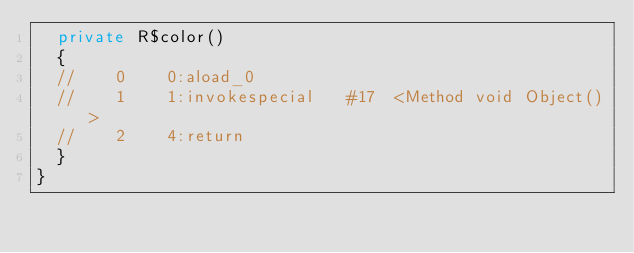Convert code to text. <code><loc_0><loc_0><loc_500><loc_500><_Java_>	private R$color()
	{
	//    0    0:aload_0         
	//    1    1:invokespecial   #17  <Method void Object()>
	//    2    4:return          
	}
}
</code> 